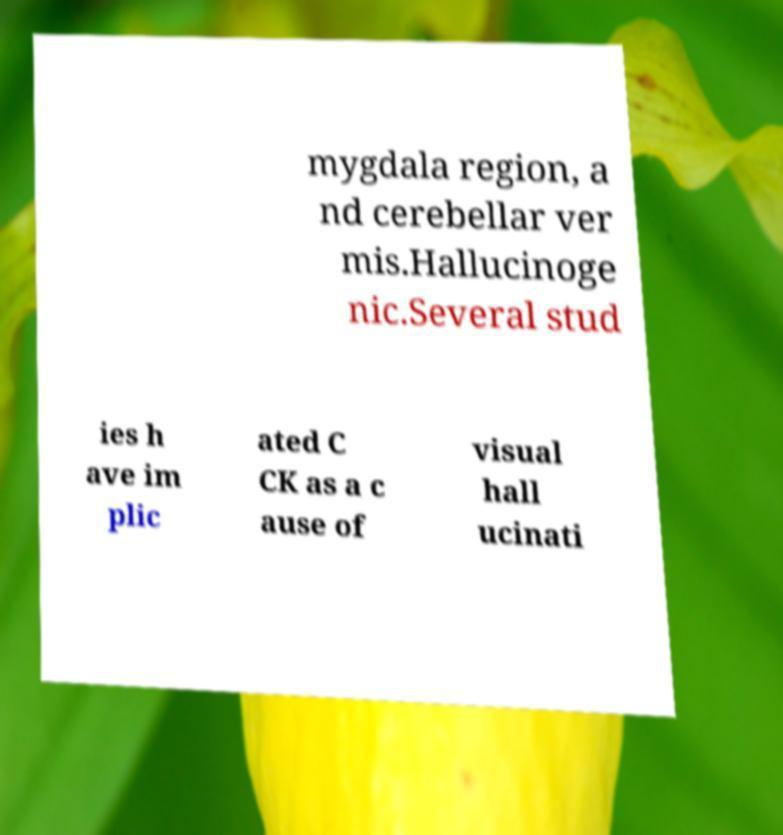Please identify and transcribe the text found in this image. mygdala region, a nd cerebellar ver mis.Hallucinoge nic.Several stud ies h ave im plic ated C CK as a c ause of visual hall ucinati 